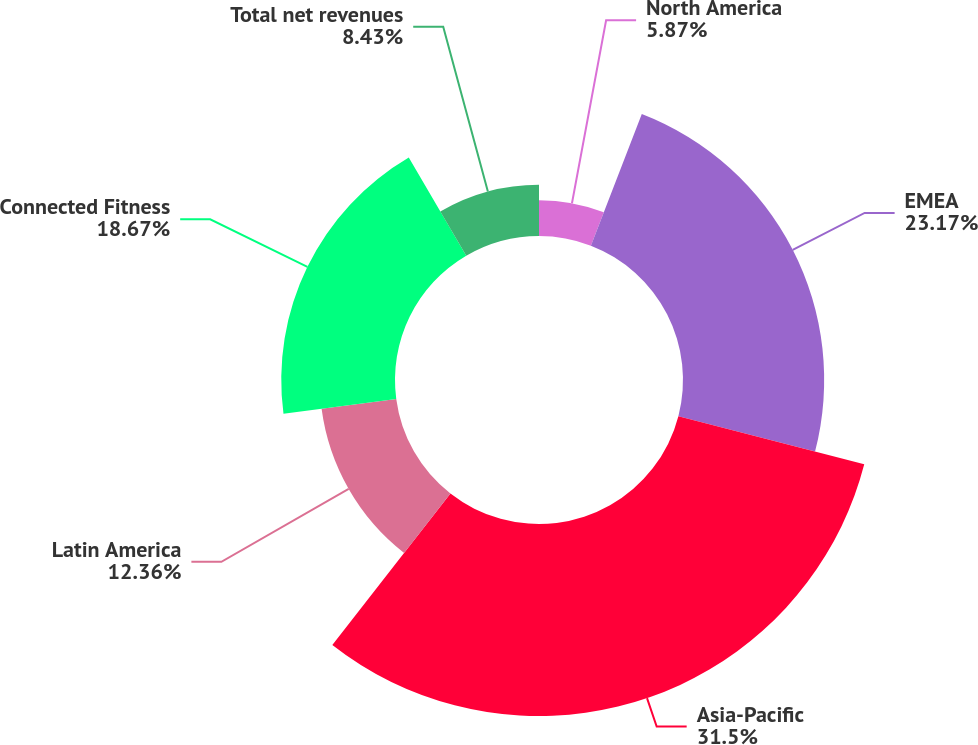Convert chart. <chart><loc_0><loc_0><loc_500><loc_500><pie_chart><fcel>North America<fcel>EMEA<fcel>Asia-Pacific<fcel>Latin America<fcel>Connected Fitness<fcel>Total net revenues<nl><fcel>5.87%<fcel>23.17%<fcel>31.51%<fcel>12.36%<fcel>18.67%<fcel>8.43%<nl></chart> 